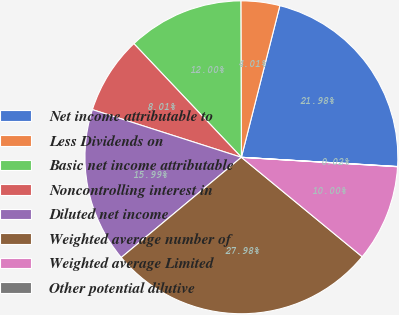<chart> <loc_0><loc_0><loc_500><loc_500><pie_chart><fcel>Net income attributable to<fcel>Less Dividends on<fcel>Basic net income attributable<fcel>Noncontrolling interest in<fcel>Diluted net income<fcel>Weighted average number of<fcel>Weighted average Limited<fcel>Other potential dilutive<nl><fcel>21.98%<fcel>4.01%<fcel>12.0%<fcel>8.01%<fcel>15.99%<fcel>27.97%<fcel>10.0%<fcel>0.02%<nl></chart> 